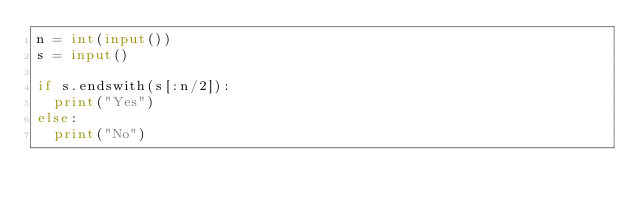Convert code to text. <code><loc_0><loc_0><loc_500><loc_500><_Python_>n = int(input())
s = input()

if s.endswith(s[:n/2]):
  print("Yes")
else:
  print("No")</code> 